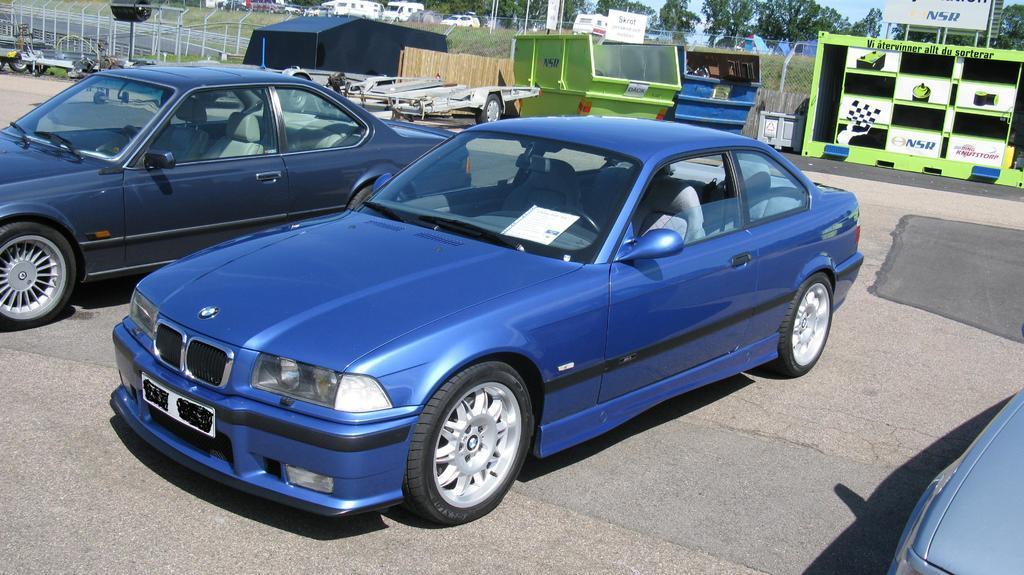In one or two sentences, can you explain what this image depicts? In this image I can see some cars and other vehicles parked on the road. I can see metal cabins, hoardings with some text and depictions. At the top of the image I can see the trees and the sky. 